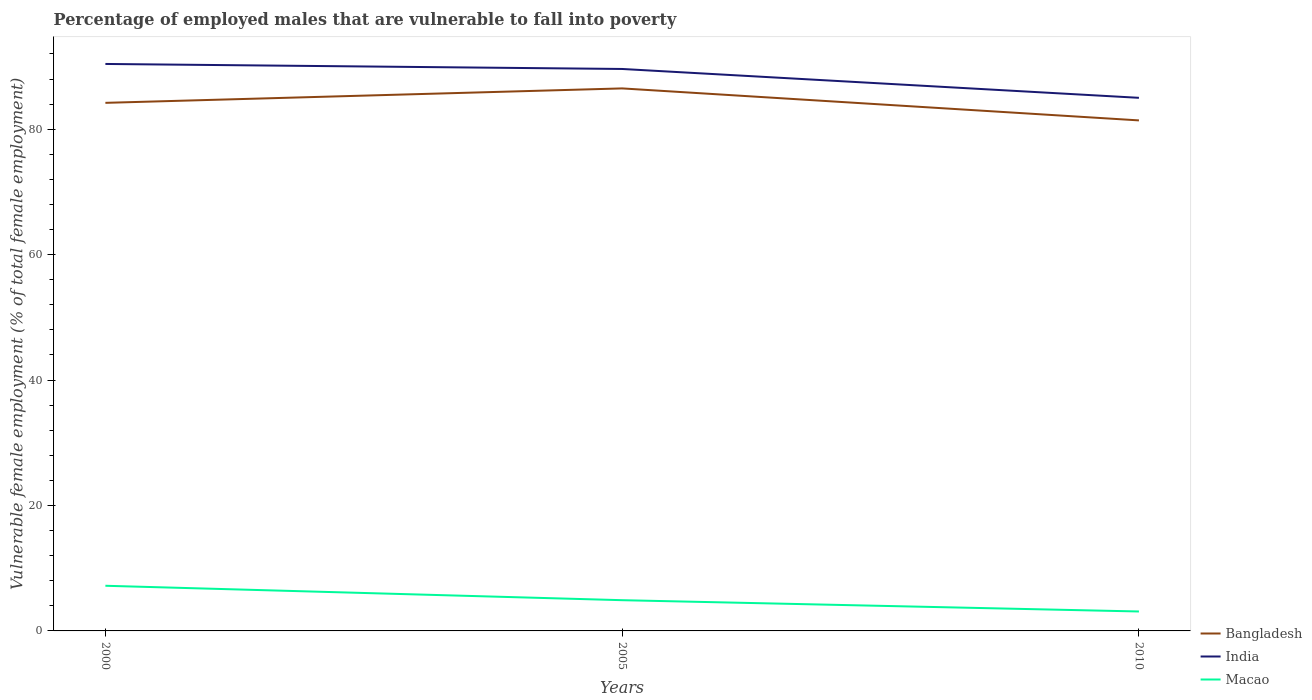How many different coloured lines are there?
Keep it short and to the point. 3. Is the number of lines equal to the number of legend labels?
Your response must be concise. Yes. In which year was the percentage of employed males who are vulnerable to fall into poverty in India maximum?
Your answer should be very brief. 2010. What is the total percentage of employed males who are vulnerable to fall into poverty in Bangladesh in the graph?
Offer a terse response. 5.1. What is the difference between the highest and the second highest percentage of employed males who are vulnerable to fall into poverty in Bangladesh?
Your answer should be very brief. 5.1. What is the difference between the highest and the lowest percentage of employed males who are vulnerable to fall into poverty in Bangladesh?
Provide a short and direct response. 2. Are the values on the major ticks of Y-axis written in scientific E-notation?
Keep it short and to the point. No. Does the graph contain grids?
Offer a terse response. No. What is the title of the graph?
Give a very brief answer. Percentage of employed males that are vulnerable to fall into poverty. Does "Ghana" appear as one of the legend labels in the graph?
Provide a short and direct response. No. What is the label or title of the Y-axis?
Make the answer very short. Vulnerable female employment (% of total female employment). What is the Vulnerable female employment (% of total female employment) in Bangladesh in 2000?
Offer a terse response. 84.2. What is the Vulnerable female employment (% of total female employment) of India in 2000?
Provide a short and direct response. 90.4. What is the Vulnerable female employment (% of total female employment) of Macao in 2000?
Provide a short and direct response. 7.2. What is the Vulnerable female employment (% of total female employment) of Bangladesh in 2005?
Your response must be concise. 86.5. What is the Vulnerable female employment (% of total female employment) of India in 2005?
Provide a succinct answer. 89.6. What is the Vulnerable female employment (% of total female employment) in Macao in 2005?
Your answer should be compact. 4.9. What is the Vulnerable female employment (% of total female employment) in Bangladesh in 2010?
Provide a succinct answer. 81.4. What is the Vulnerable female employment (% of total female employment) of India in 2010?
Your answer should be very brief. 85. What is the Vulnerable female employment (% of total female employment) of Macao in 2010?
Ensure brevity in your answer.  3.1. Across all years, what is the maximum Vulnerable female employment (% of total female employment) of Bangladesh?
Offer a terse response. 86.5. Across all years, what is the maximum Vulnerable female employment (% of total female employment) in India?
Ensure brevity in your answer.  90.4. Across all years, what is the maximum Vulnerable female employment (% of total female employment) in Macao?
Ensure brevity in your answer.  7.2. Across all years, what is the minimum Vulnerable female employment (% of total female employment) of Bangladesh?
Offer a very short reply. 81.4. Across all years, what is the minimum Vulnerable female employment (% of total female employment) in Macao?
Provide a succinct answer. 3.1. What is the total Vulnerable female employment (% of total female employment) of Bangladesh in the graph?
Ensure brevity in your answer.  252.1. What is the total Vulnerable female employment (% of total female employment) in India in the graph?
Provide a succinct answer. 265. What is the total Vulnerable female employment (% of total female employment) in Macao in the graph?
Provide a succinct answer. 15.2. What is the difference between the Vulnerable female employment (% of total female employment) in Bangladesh in 2000 and that in 2005?
Your response must be concise. -2.3. What is the difference between the Vulnerable female employment (% of total female employment) of India in 2000 and that in 2005?
Offer a very short reply. 0.8. What is the difference between the Vulnerable female employment (% of total female employment) of Macao in 2000 and that in 2005?
Ensure brevity in your answer.  2.3. What is the difference between the Vulnerable female employment (% of total female employment) of India in 2000 and that in 2010?
Provide a short and direct response. 5.4. What is the difference between the Vulnerable female employment (% of total female employment) of India in 2005 and that in 2010?
Keep it short and to the point. 4.6. What is the difference between the Vulnerable female employment (% of total female employment) in Bangladesh in 2000 and the Vulnerable female employment (% of total female employment) in India in 2005?
Make the answer very short. -5.4. What is the difference between the Vulnerable female employment (% of total female employment) of Bangladesh in 2000 and the Vulnerable female employment (% of total female employment) of Macao in 2005?
Offer a terse response. 79.3. What is the difference between the Vulnerable female employment (% of total female employment) in India in 2000 and the Vulnerable female employment (% of total female employment) in Macao in 2005?
Your answer should be very brief. 85.5. What is the difference between the Vulnerable female employment (% of total female employment) in Bangladesh in 2000 and the Vulnerable female employment (% of total female employment) in India in 2010?
Offer a terse response. -0.8. What is the difference between the Vulnerable female employment (% of total female employment) in Bangladesh in 2000 and the Vulnerable female employment (% of total female employment) in Macao in 2010?
Provide a succinct answer. 81.1. What is the difference between the Vulnerable female employment (% of total female employment) in India in 2000 and the Vulnerable female employment (% of total female employment) in Macao in 2010?
Give a very brief answer. 87.3. What is the difference between the Vulnerable female employment (% of total female employment) in Bangladesh in 2005 and the Vulnerable female employment (% of total female employment) in Macao in 2010?
Provide a short and direct response. 83.4. What is the difference between the Vulnerable female employment (% of total female employment) of India in 2005 and the Vulnerable female employment (% of total female employment) of Macao in 2010?
Your response must be concise. 86.5. What is the average Vulnerable female employment (% of total female employment) in Bangladesh per year?
Keep it short and to the point. 84.03. What is the average Vulnerable female employment (% of total female employment) in India per year?
Provide a short and direct response. 88.33. What is the average Vulnerable female employment (% of total female employment) in Macao per year?
Offer a very short reply. 5.07. In the year 2000, what is the difference between the Vulnerable female employment (% of total female employment) in Bangladesh and Vulnerable female employment (% of total female employment) in Macao?
Offer a terse response. 77. In the year 2000, what is the difference between the Vulnerable female employment (% of total female employment) in India and Vulnerable female employment (% of total female employment) in Macao?
Offer a terse response. 83.2. In the year 2005, what is the difference between the Vulnerable female employment (% of total female employment) in Bangladesh and Vulnerable female employment (% of total female employment) in India?
Offer a very short reply. -3.1. In the year 2005, what is the difference between the Vulnerable female employment (% of total female employment) in Bangladesh and Vulnerable female employment (% of total female employment) in Macao?
Provide a succinct answer. 81.6. In the year 2005, what is the difference between the Vulnerable female employment (% of total female employment) of India and Vulnerable female employment (% of total female employment) of Macao?
Ensure brevity in your answer.  84.7. In the year 2010, what is the difference between the Vulnerable female employment (% of total female employment) of Bangladesh and Vulnerable female employment (% of total female employment) of India?
Offer a very short reply. -3.6. In the year 2010, what is the difference between the Vulnerable female employment (% of total female employment) of Bangladesh and Vulnerable female employment (% of total female employment) of Macao?
Offer a terse response. 78.3. In the year 2010, what is the difference between the Vulnerable female employment (% of total female employment) in India and Vulnerable female employment (% of total female employment) in Macao?
Give a very brief answer. 81.9. What is the ratio of the Vulnerable female employment (% of total female employment) in Bangladesh in 2000 to that in 2005?
Keep it short and to the point. 0.97. What is the ratio of the Vulnerable female employment (% of total female employment) of India in 2000 to that in 2005?
Make the answer very short. 1.01. What is the ratio of the Vulnerable female employment (% of total female employment) of Macao in 2000 to that in 2005?
Your answer should be very brief. 1.47. What is the ratio of the Vulnerable female employment (% of total female employment) of Bangladesh in 2000 to that in 2010?
Ensure brevity in your answer.  1.03. What is the ratio of the Vulnerable female employment (% of total female employment) of India in 2000 to that in 2010?
Offer a very short reply. 1.06. What is the ratio of the Vulnerable female employment (% of total female employment) in Macao in 2000 to that in 2010?
Your answer should be compact. 2.32. What is the ratio of the Vulnerable female employment (% of total female employment) of Bangladesh in 2005 to that in 2010?
Keep it short and to the point. 1.06. What is the ratio of the Vulnerable female employment (% of total female employment) in India in 2005 to that in 2010?
Your answer should be very brief. 1.05. What is the ratio of the Vulnerable female employment (% of total female employment) in Macao in 2005 to that in 2010?
Provide a succinct answer. 1.58. What is the difference between the highest and the second highest Vulnerable female employment (% of total female employment) in Bangladesh?
Offer a terse response. 2.3. What is the difference between the highest and the second highest Vulnerable female employment (% of total female employment) of India?
Give a very brief answer. 0.8. What is the difference between the highest and the second highest Vulnerable female employment (% of total female employment) of Macao?
Your answer should be compact. 2.3. What is the difference between the highest and the lowest Vulnerable female employment (% of total female employment) of Bangladesh?
Ensure brevity in your answer.  5.1. What is the difference between the highest and the lowest Vulnerable female employment (% of total female employment) of Macao?
Provide a succinct answer. 4.1. 